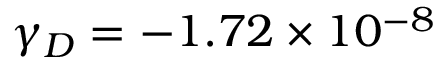Convert formula to latex. <formula><loc_0><loc_0><loc_500><loc_500>{ \gamma } _ { D } = - 1 . 7 2 \times 1 0 ^ { - 8 }</formula> 